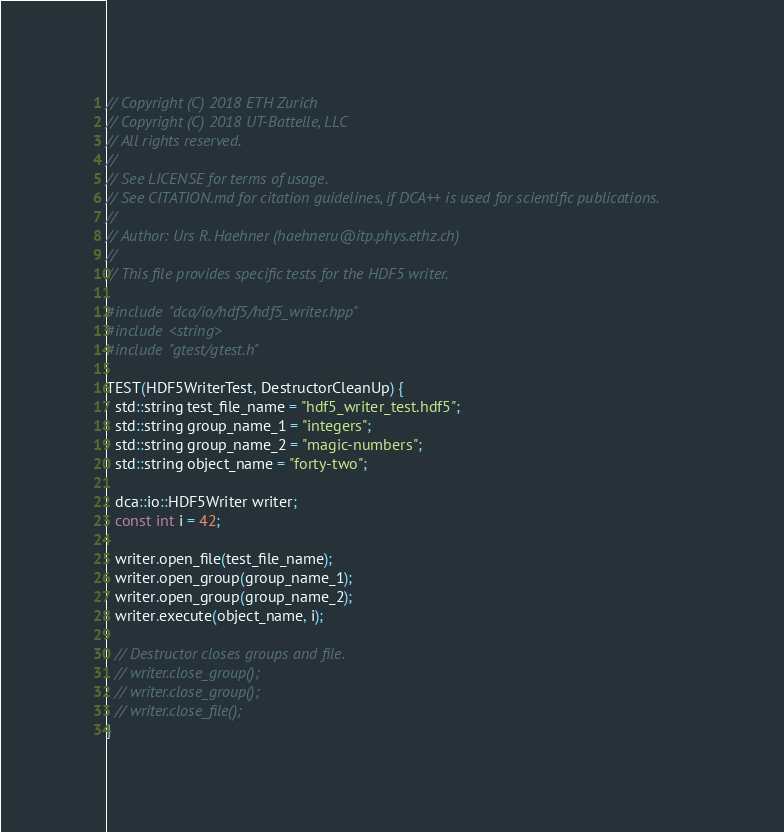<code> <loc_0><loc_0><loc_500><loc_500><_C++_>// Copyright (C) 2018 ETH Zurich
// Copyright (C) 2018 UT-Battelle, LLC
// All rights reserved.
//
// See LICENSE for terms of usage.
// See CITATION.md for citation guidelines, if DCA++ is used for scientific publications.
//
// Author: Urs R. Haehner (haehneru@itp.phys.ethz.ch)
//
// This file provides specific tests for the HDF5 writer.

#include "dca/io/hdf5/hdf5_writer.hpp"
#include <string>
#include "gtest/gtest.h"

TEST(HDF5WriterTest, DestructorCleanUp) {
  std::string test_file_name = "hdf5_writer_test.hdf5";
  std::string group_name_1 = "integers";
  std::string group_name_2 = "magic-numbers";
  std::string object_name = "forty-two";

  dca::io::HDF5Writer writer;
  const int i = 42;

  writer.open_file(test_file_name);
  writer.open_group(group_name_1);
  writer.open_group(group_name_2);
  writer.execute(object_name, i);

  // Destructor closes groups and file.
  // writer.close_group();
  // writer.close_group();
  // writer.close_file();
}
</code> 